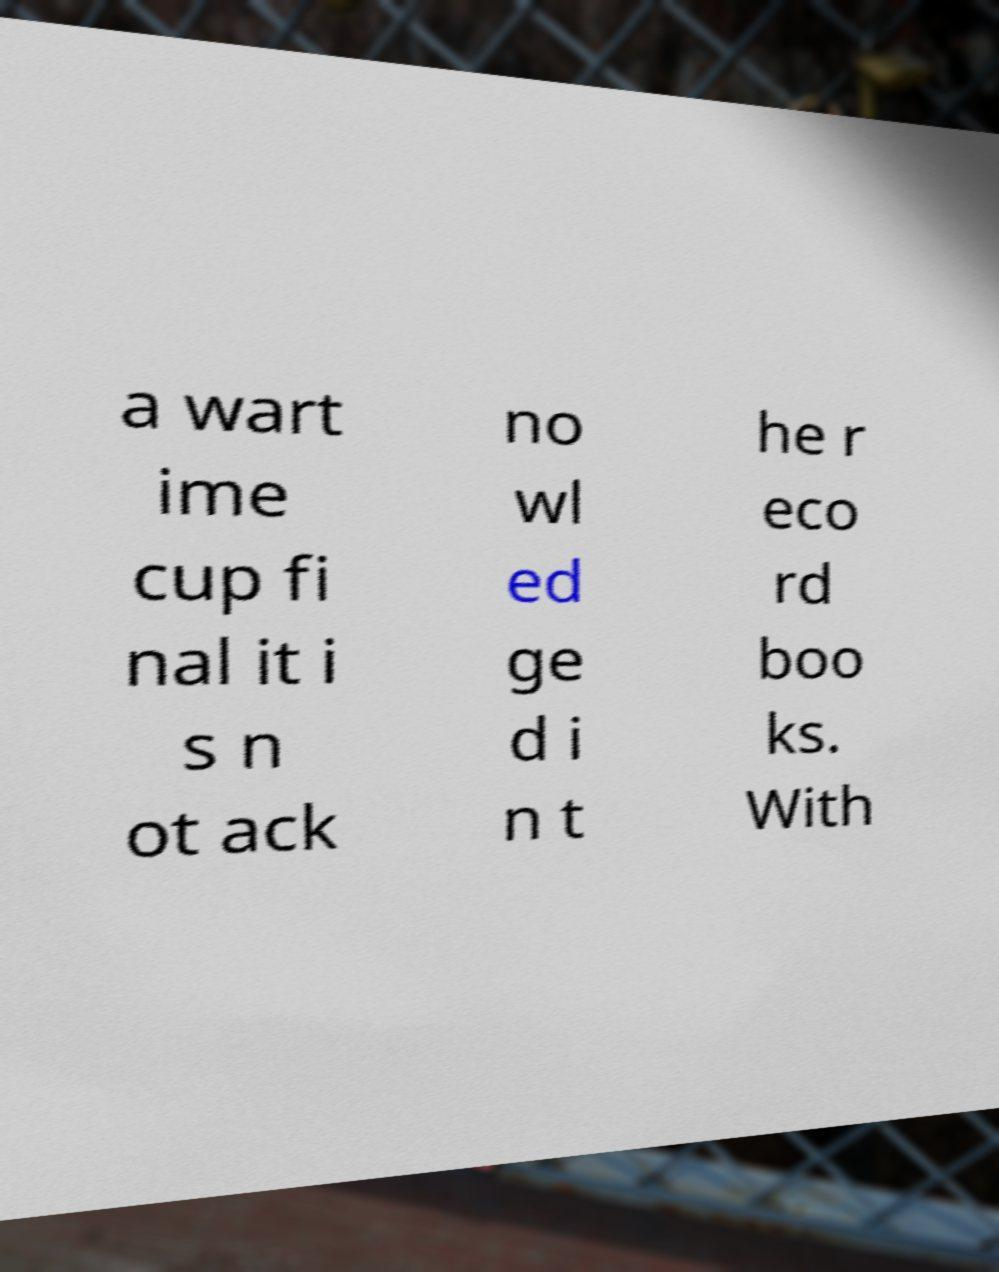Please identify and transcribe the text found in this image. a wart ime cup fi nal it i s n ot ack no wl ed ge d i n t he r eco rd boo ks. With 